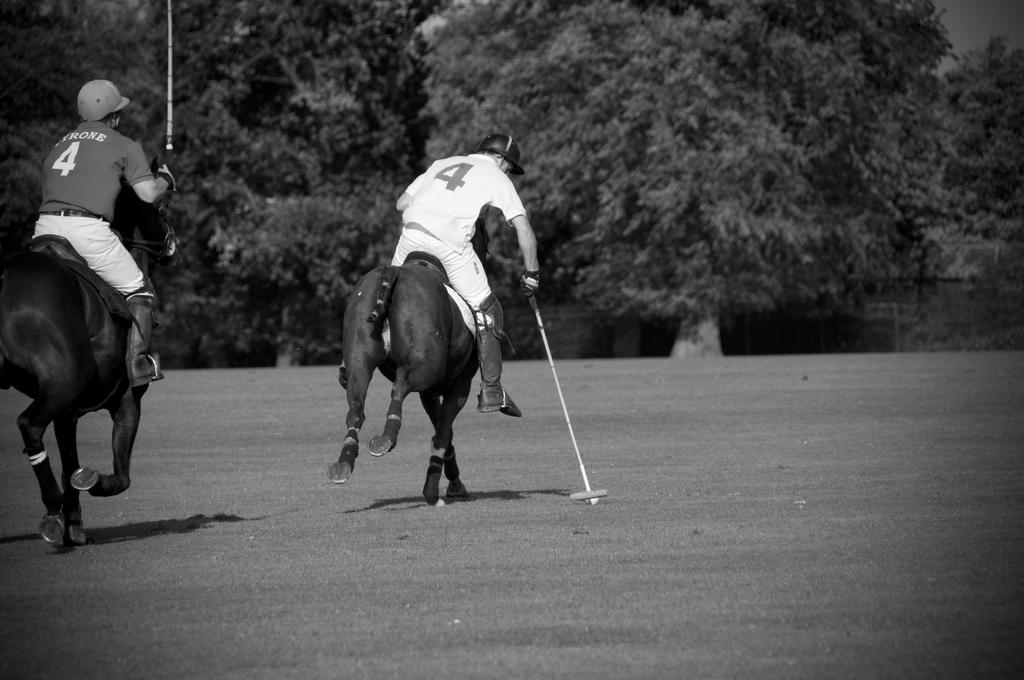How many people are in the image? There are two men in the image. What are the men doing in the image? The men are sitting on animals and riding them. What are the men wearing on their heads? The men are wearing caps. What is the color scheme of the image? The image is in black and white. What type of natural environment can be seen in the image? There are trees visible in the image. What type of soup is being served for dinner in the image? There is no reference to soup or dinner in the image; it features two men riding animals. 